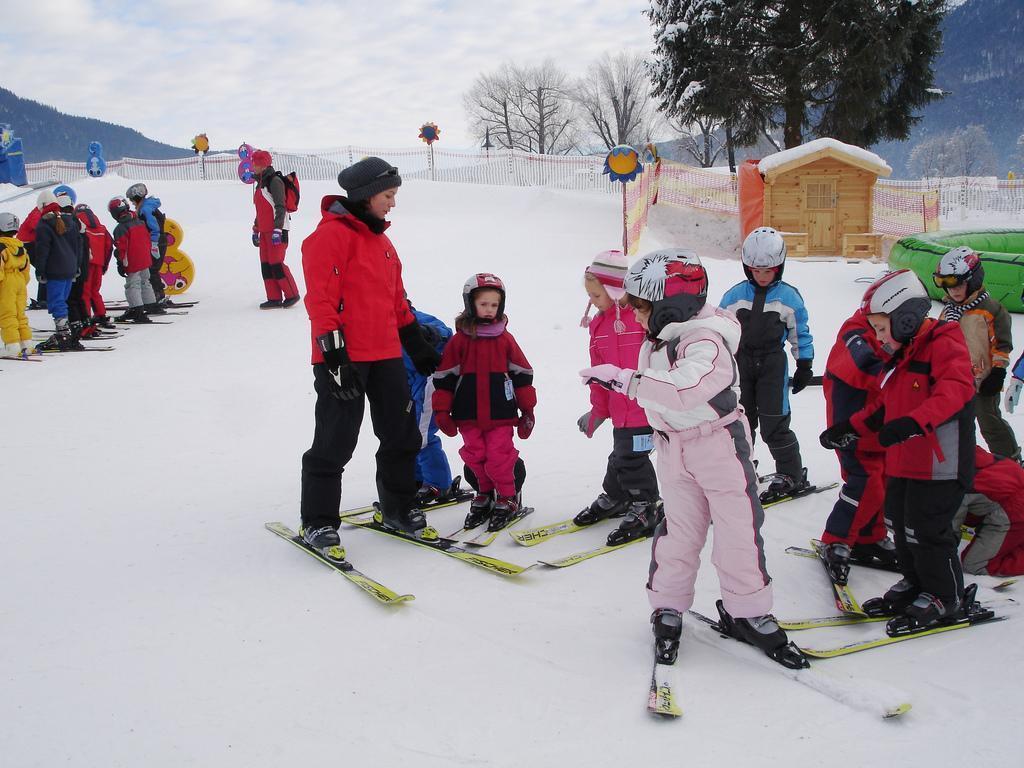How many people are in light pink jackets?
Give a very brief answer. 1. How many buildings are in the photo?
Give a very brief answer. 1. How many trees with leaves are there?
Give a very brief answer. 1. How many people are wearing pink suits?
Give a very brief answer. 2. 